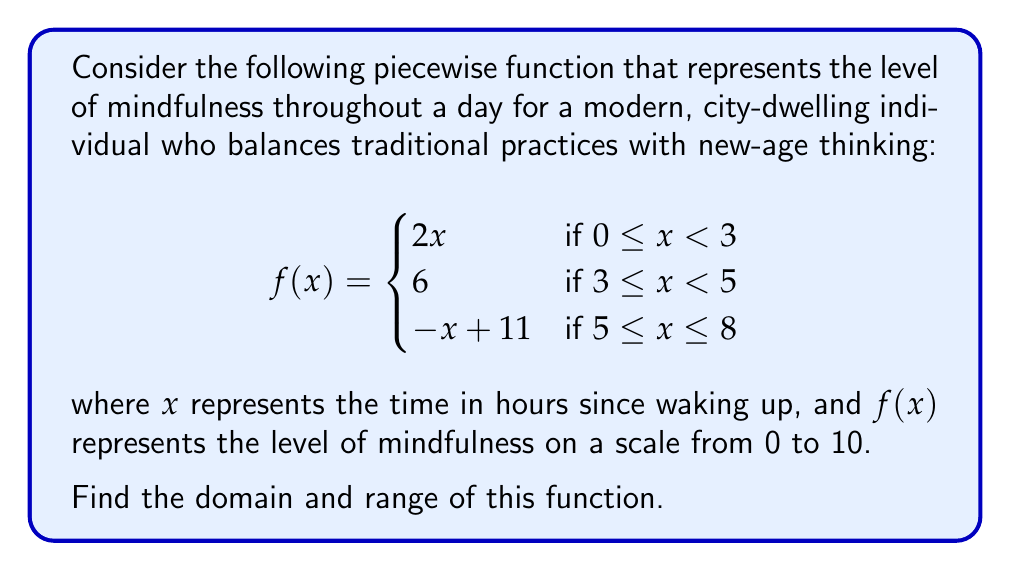Teach me how to tackle this problem. To find the domain and range of this piecewise function, we need to analyze each piece separately and then combine the results.

1. Domain:
   The domain is the set of all possible input values (x-values) for the function.
   - For the first piece: $0 \leq x < 3$
   - For the second piece: $3 \leq x < 5$
   - For the third piece: $5 \leq x \leq 8$
   
   Combining these intervals, we get the domain: $[0, 8]$

2. Range:
   The range is the set of all possible output values (y-values) for the function.
   
   a) For $0 \leq x < 3$: $f(x) = 2x$
      - When $x = 0$, $f(0) = 0$
      - When $x$ approaches 3, $f(x)$ approaches 6
      So, the range for this piece is $[0, 6)$
   
   b) For $3 \leq x < 5$: $f(x) = 6$
      The range for this piece is the single value {6}
   
   c) For $5 \leq x \leq 8$: $f(x) = -x + 11$
      - When $x = 5$, $f(5) = 6$
      - When $x = 8$, $f(8) = 3$
      So, the range for this piece is $[3, 6]$
   
   Combining these ranges, we get: $[0, 6]$

Therefore, the range of the entire function is $[0, 6]$.
Answer: Domain: $[0, 8]$
Range: $[0, 6]$ 